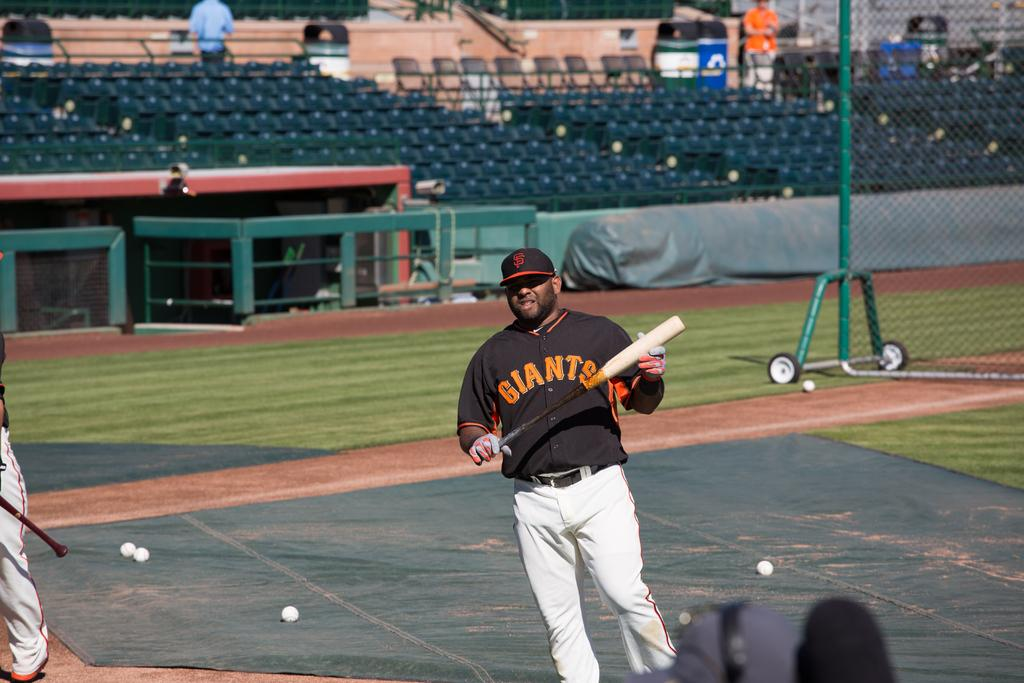<image>
Present a compact description of the photo's key features. a giants baseball player holding a black and white bat 